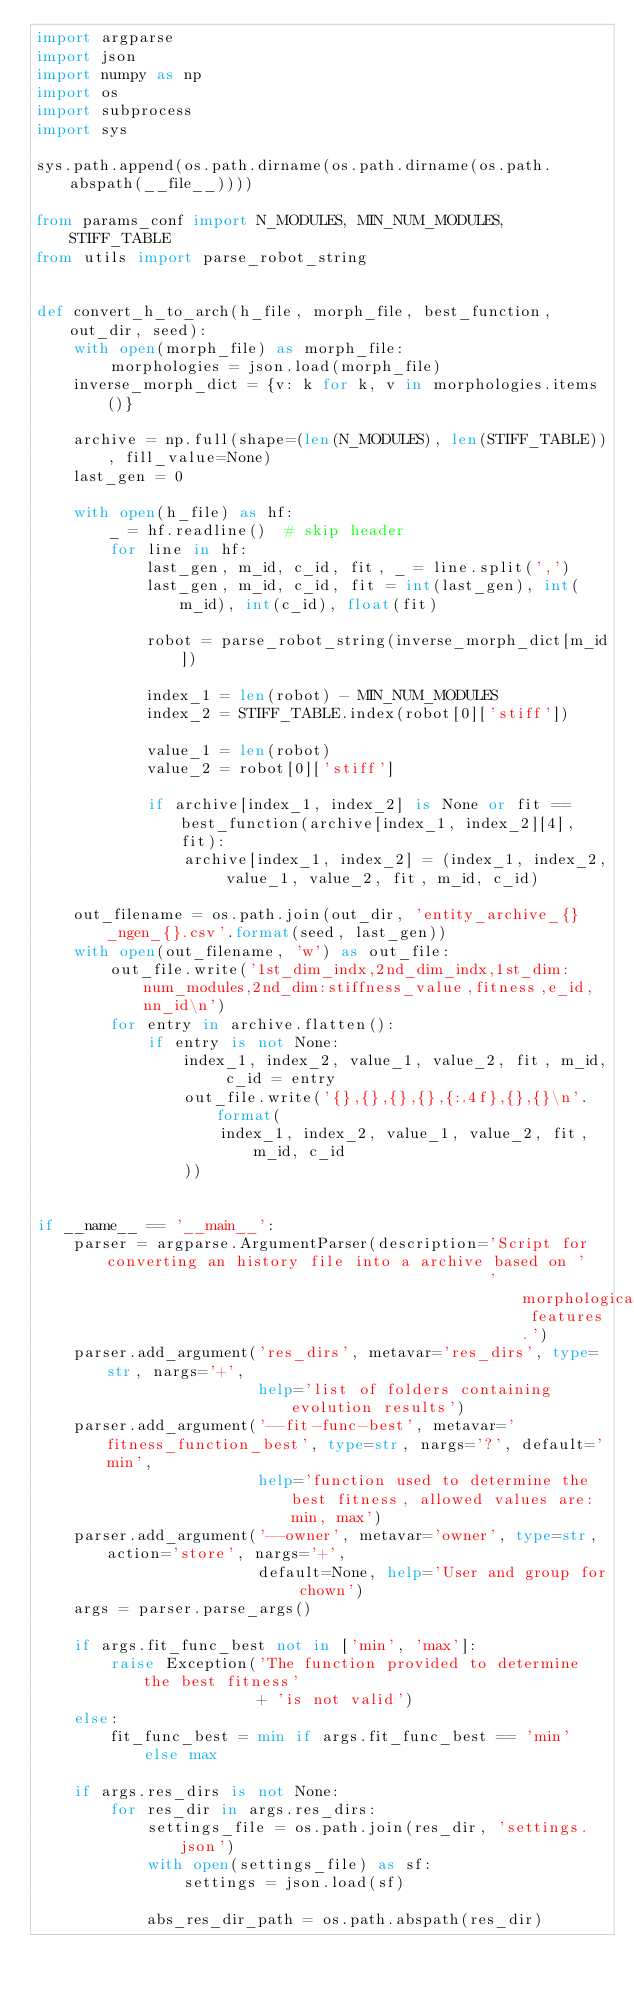<code> <loc_0><loc_0><loc_500><loc_500><_Python_>import argparse
import json
import numpy as np
import os
import subprocess
import sys

sys.path.append(os.path.dirname(os.path.dirname(os.path.abspath(__file__))))

from params_conf import N_MODULES, MIN_NUM_MODULES, STIFF_TABLE
from utils import parse_robot_string


def convert_h_to_arch(h_file, morph_file, best_function, out_dir, seed):
    with open(morph_file) as morph_file:
        morphologies = json.load(morph_file)
    inverse_morph_dict = {v: k for k, v in morphologies.items()}

    archive = np.full(shape=(len(N_MODULES), len(STIFF_TABLE)), fill_value=None)
    last_gen = 0

    with open(h_file) as hf:
        _ = hf.readline()  # skip header
        for line in hf:
            last_gen, m_id, c_id, fit, _ = line.split(',')
            last_gen, m_id, c_id, fit = int(last_gen), int(m_id), int(c_id), float(fit)

            robot = parse_robot_string(inverse_morph_dict[m_id])

            index_1 = len(robot) - MIN_NUM_MODULES
            index_2 = STIFF_TABLE.index(robot[0]['stiff'])

            value_1 = len(robot)
            value_2 = robot[0]['stiff']

            if archive[index_1, index_2] is None or fit == best_function(archive[index_1, index_2][4], fit):
                archive[index_1, index_2] = (index_1, index_2, value_1, value_2, fit, m_id, c_id)

    out_filename = os.path.join(out_dir, 'entity_archive_{}_ngen_{}.csv'.format(seed, last_gen))
    with open(out_filename, 'w') as out_file:
        out_file.write('1st_dim_indx,2nd_dim_indx,1st_dim:num_modules,2nd_dim:stiffness_value,fitness,e_id,nn_id\n')
        for entry in archive.flatten():
            if entry is not None:
                index_1, index_2, value_1, value_2, fit, m_id, c_id = entry
                out_file.write('{},{},{},{},{:.4f},{},{}\n'.format(
                    index_1, index_2, value_1, value_2, fit, m_id, c_id
                ))


if __name__ == '__main__':
    parser = argparse.ArgumentParser(description='Script for converting an history file into a archive based on '
                                                 'morphological features.')
    parser.add_argument('res_dirs', metavar='res_dirs', type=str, nargs='+',
                        help='list of folders containing evolution results')
    parser.add_argument('--fit-func-best', metavar='fitness_function_best', type=str, nargs='?', default='min',
                        help='function used to determine the best fitness, allowed values are: min, max')
    parser.add_argument('--owner', metavar='owner', type=str, action='store', nargs='+',
                        default=None, help='User and group for chown')
    args = parser.parse_args()

    if args.fit_func_best not in ['min', 'max']:
        raise Exception('The function provided to determine the best fitness'
                        + 'is not valid')
    else:
        fit_func_best = min if args.fit_func_best == 'min' else max

    if args.res_dirs is not None:
        for res_dir in args.res_dirs:
            settings_file = os.path.join(res_dir, 'settings.json')
            with open(settings_file) as sf:
                settings = json.load(sf)

            abs_res_dir_path = os.path.abspath(res_dir)</code> 